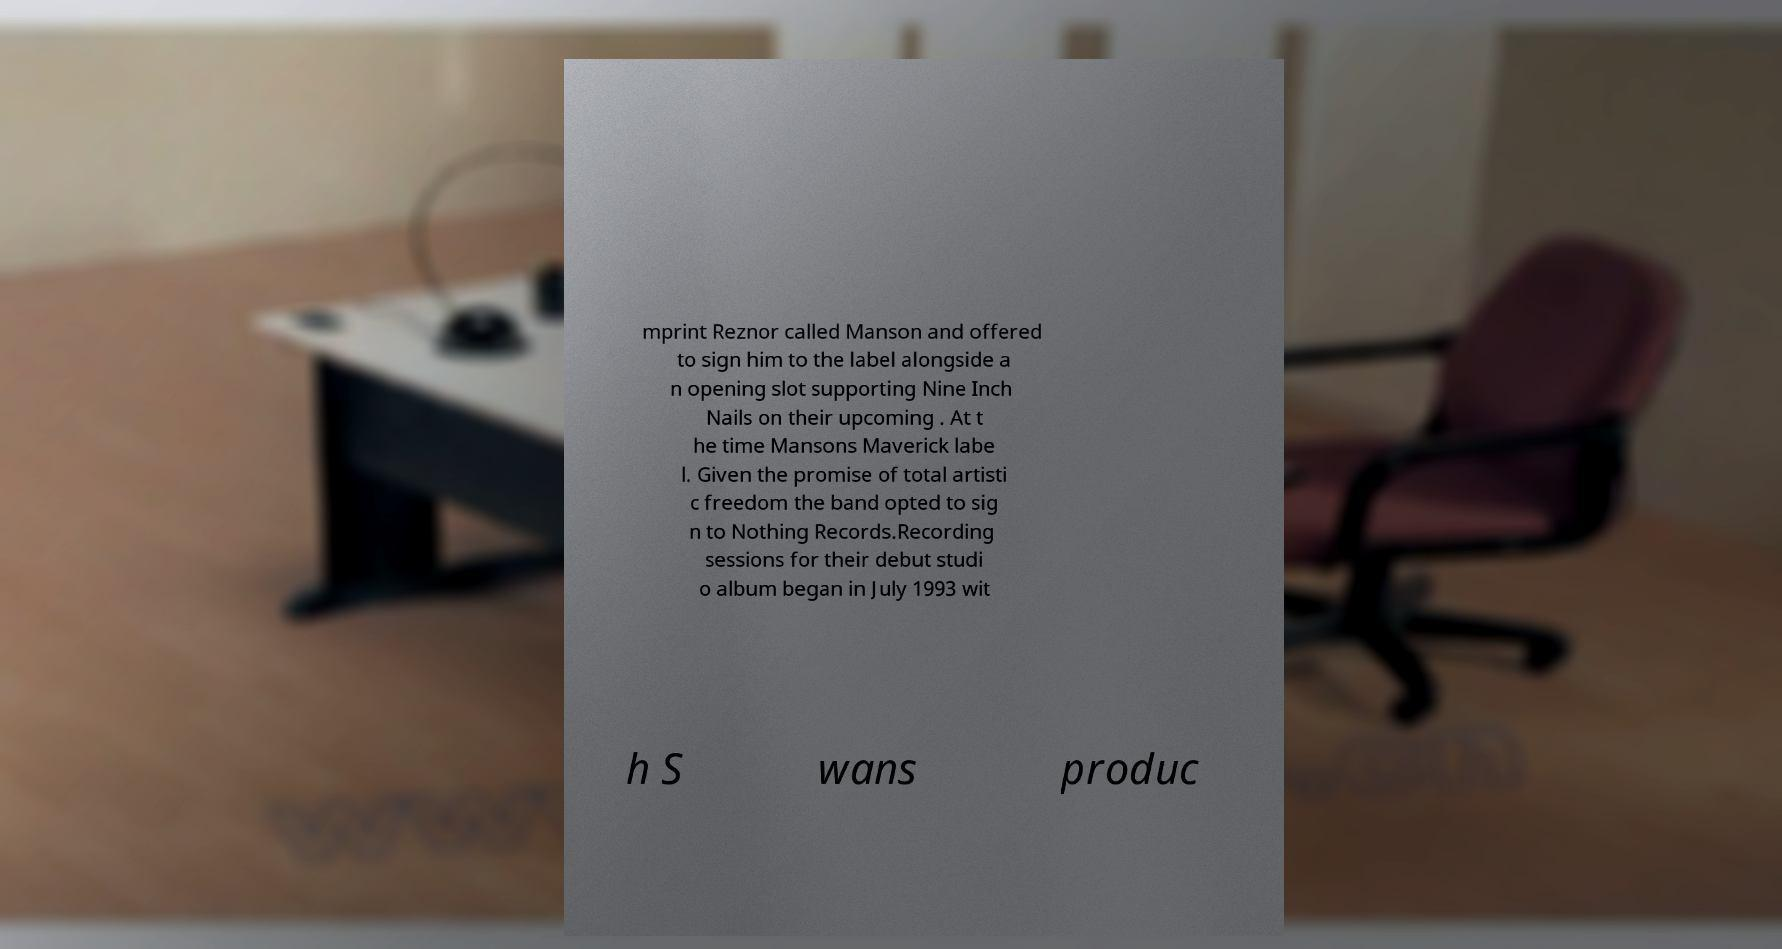Could you extract and type out the text from this image? mprint Reznor called Manson and offered to sign him to the label alongside a n opening slot supporting Nine Inch Nails on their upcoming . At t he time Mansons Maverick labe l. Given the promise of total artisti c freedom the band opted to sig n to Nothing Records.Recording sessions for their debut studi o album began in July 1993 wit h S wans produc 